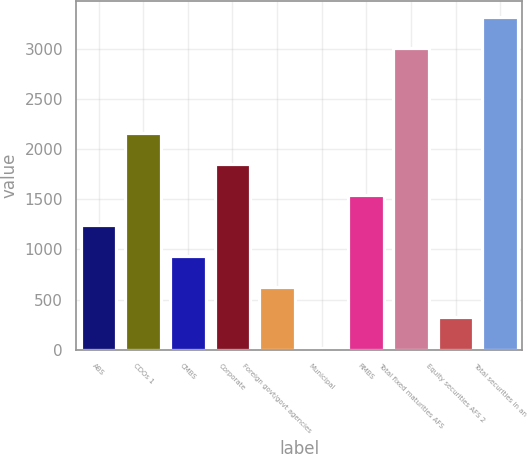<chart> <loc_0><loc_0><loc_500><loc_500><bar_chart><fcel>ABS<fcel>CDOs 1<fcel>CMBS<fcel>Corporate<fcel>Foreign govt/govt agencies<fcel>Municipal<fcel>RMBS<fcel>Total fixed maturities AFS<fcel>Equity securities AFS 2<fcel>Total securities in an<nl><fcel>1239.6<fcel>2155.8<fcel>934.2<fcel>1850.4<fcel>628.8<fcel>18<fcel>1545<fcel>3010<fcel>323.4<fcel>3315.4<nl></chart> 